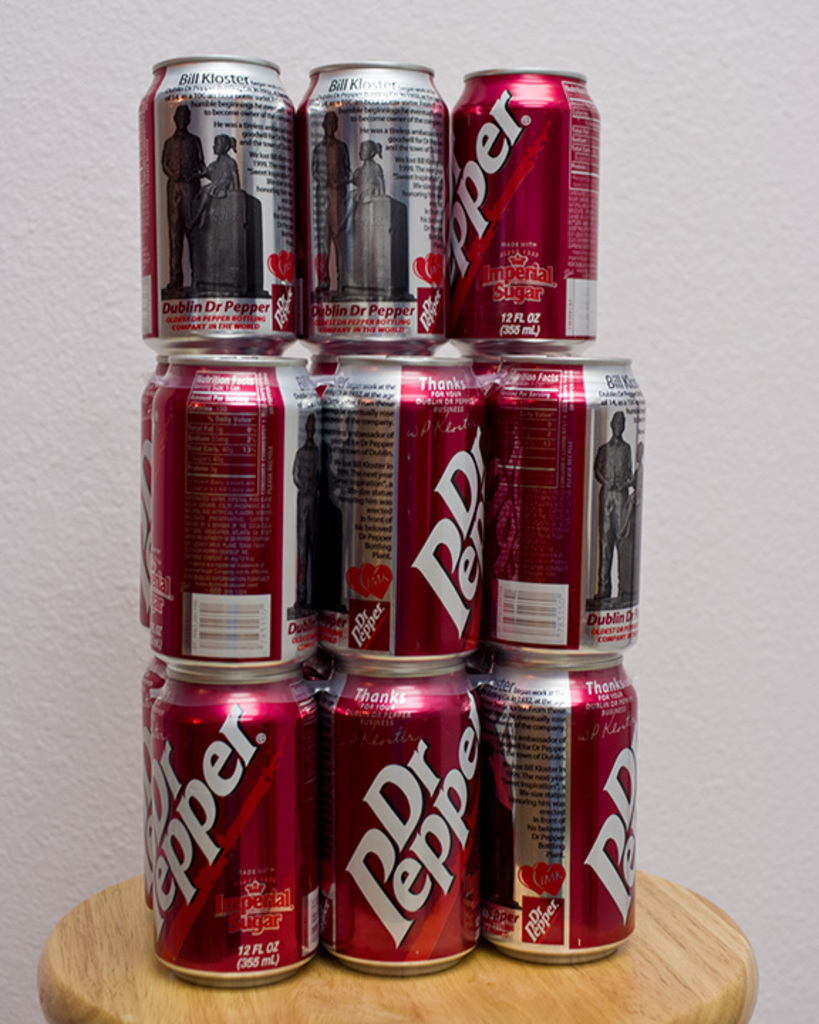Provide a one-sentence caption for the provided image. A meticulously arranged pyramid of limited edition Dr Pepper cans, featuring a vintage 'Dublin Dr Pepper' label with Imperial Sugar, displayed on a simple wooden stool. 